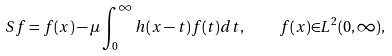Convert formula to latex. <formula><loc_0><loc_0><loc_500><loc_500>S f = f ( x ) - { \mu } \int _ { 0 } ^ { \infty } h ( x - t ) f ( t ) d t , \quad f ( x ) { \in } L ^ { 2 } ( 0 , \infty ) ,</formula> 